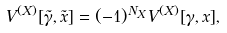<formula> <loc_0><loc_0><loc_500><loc_500>V ^ { ( X ) } [ \tilde { \gamma } , \tilde { x } ] = ( - 1 ) ^ { N _ { X } } V ^ { ( X ) } [ \gamma , x ] ,</formula> 